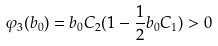<formula> <loc_0><loc_0><loc_500><loc_500>\varphi _ { 3 } ( b _ { 0 } ) = b _ { 0 } C _ { 2 } ( 1 - \frac { 1 } { 2 } b _ { 0 } C _ { 1 } ) > 0</formula> 